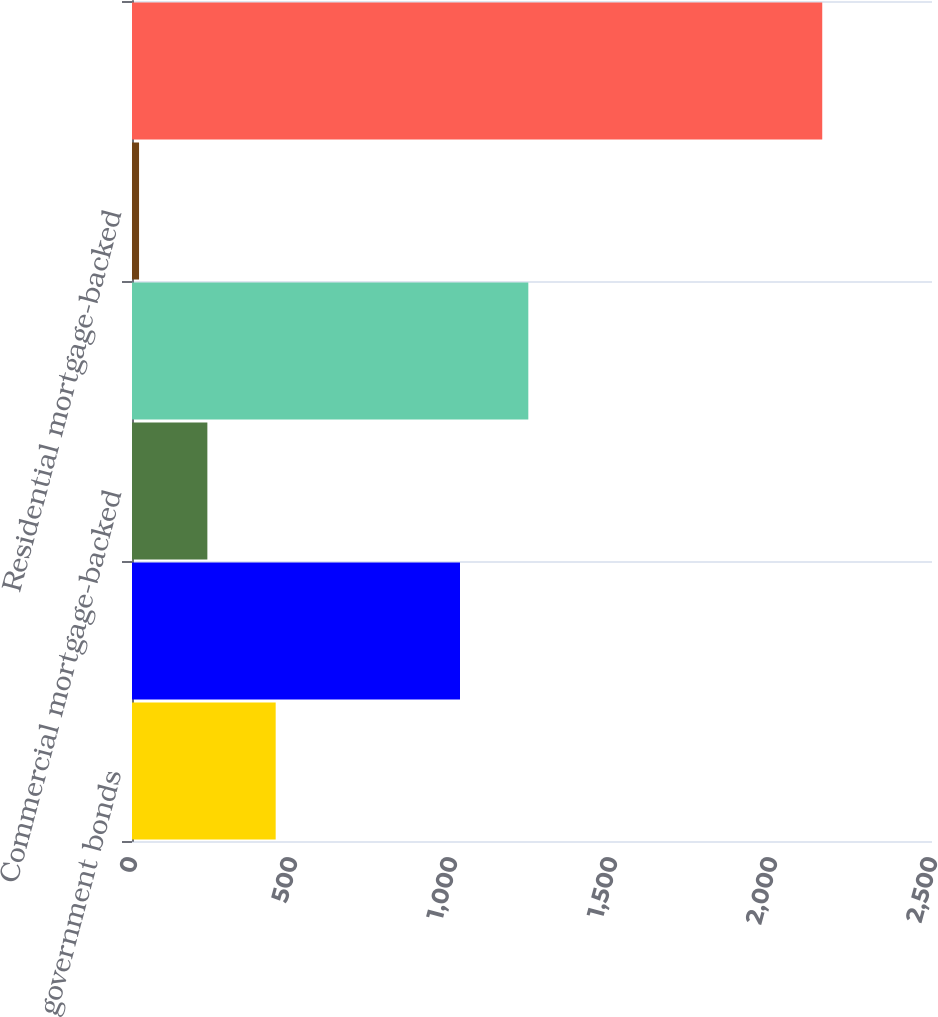Convert chart. <chart><loc_0><loc_0><loc_500><loc_500><bar_chart><fcel>Foreign government bonds<fcel>Corporate securities<fcel>Commercial mortgage-backed<fcel>Asset-backed securities<fcel>Residential mortgage-backed<fcel>Total<nl><fcel>449<fcel>1025<fcel>235.5<fcel>1238.5<fcel>22<fcel>2157<nl></chart> 